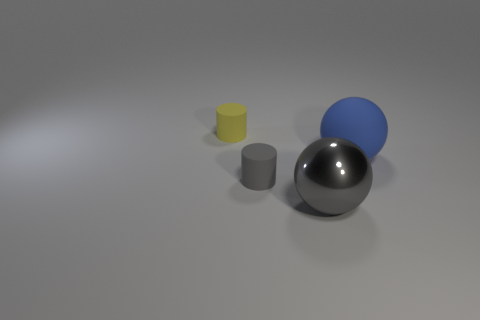The small object that is the same color as the metallic ball is what shape?
Make the answer very short. Cylinder. How many things are big blue balls behind the large gray sphere or tiny red spheres?
Provide a short and direct response. 1. Is the size of the gray sphere the same as the yellow cylinder?
Your response must be concise. No. What color is the cylinder behind the small gray cylinder?
Your answer should be very brief. Yellow. There is a blue sphere that is the same material as the tiny gray cylinder; what is its size?
Provide a succinct answer. Large. There is a gray cylinder; does it have the same size as the rubber object behind the blue matte sphere?
Make the answer very short. Yes. There is a tiny thing in front of the tiny yellow rubber thing; what is it made of?
Offer a terse response. Rubber. There is a cylinder that is in front of the big blue matte object; how many small rubber cylinders are to the left of it?
Your answer should be compact. 1. Are there any other small gray objects that have the same shape as the gray metal thing?
Provide a succinct answer. No. Does the matte thing that is right of the small gray cylinder have the same size as the matte object behind the blue thing?
Your response must be concise. No. 